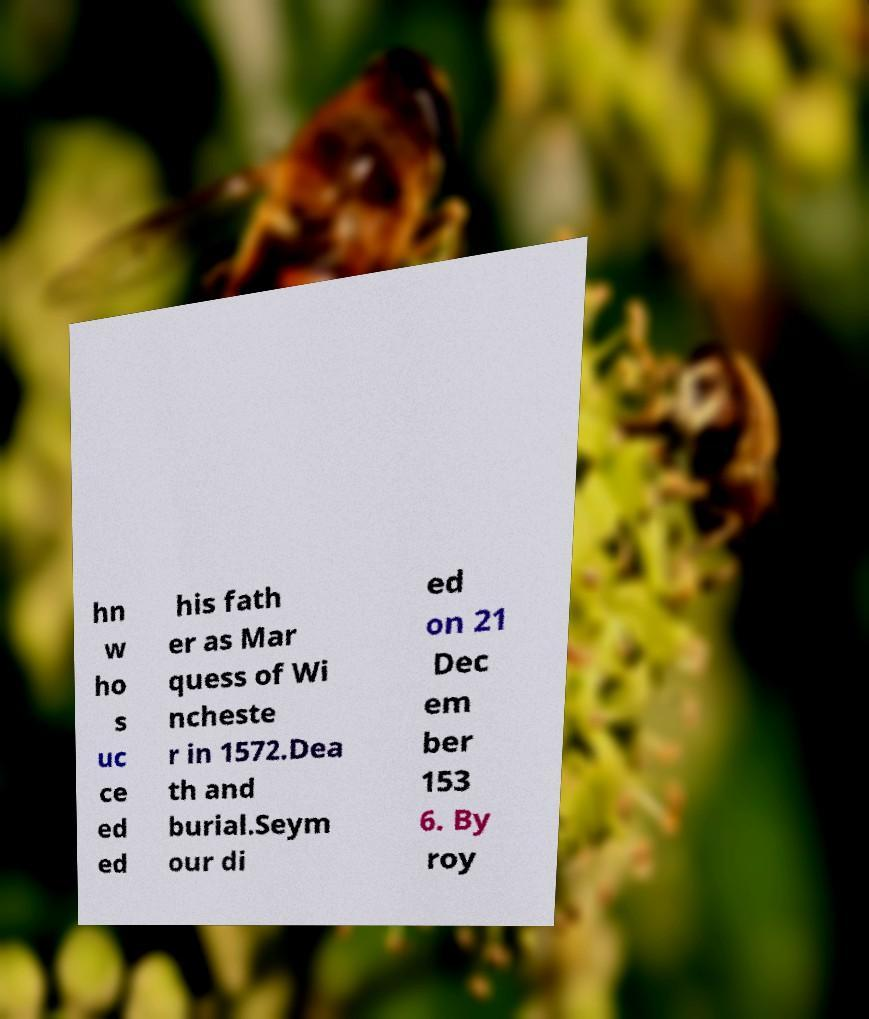Could you extract and type out the text from this image? hn w ho s uc ce ed ed his fath er as Mar quess of Wi ncheste r in 1572.Dea th and burial.Seym our di ed on 21 Dec em ber 153 6. By roy 